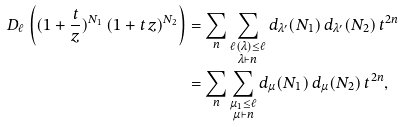Convert formula to latex. <formula><loc_0><loc_0><loc_500><loc_500>D _ { \ell } \left ( ( 1 + \frac { t } { z } ) ^ { N _ { 1 } } \, ( 1 + t \, z ) ^ { N _ { 2 } } \right ) & = \sum _ { n } \sum _ { \substack { \ell ( \lambda ) \leq \ell \\ \lambda \vdash n } } d _ { \lambda ^ { \prime } } ( N _ { 1 } ) \, d _ { \lambda ^ { \prime } } ( N _ { 2 } ) \, t ^ { 2 n } \\ & = \sum _ { n } \sum _ { \substack { \mu _ { 1 } \leq \ell \\ \mu \vdash n } } d _ { \mu } ( N _ { 1 } ) \, d _ { \mu } ( N _ { 2 } ) \, t ^ { 2 n } ,</formula> 